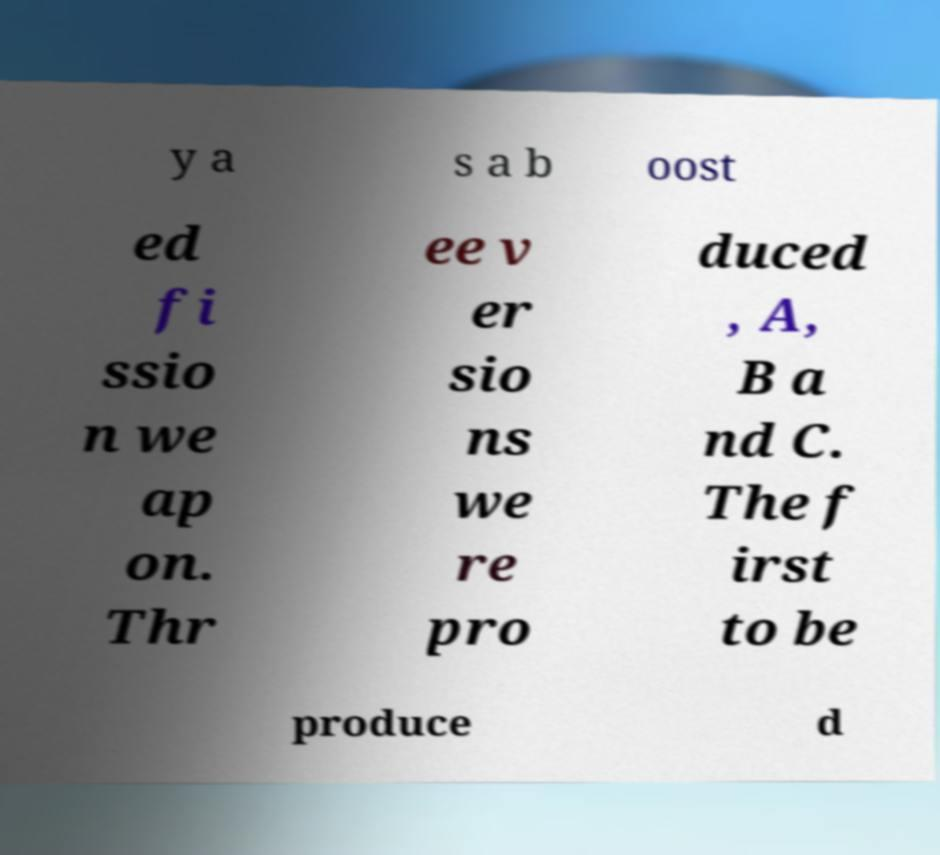Could you extract and type out the text from this image? y a s a b oost ed fi ssio n we ap on. Thr ee v er sio ns we re pro duced , A, B a nd C. The f irst to be produce d 